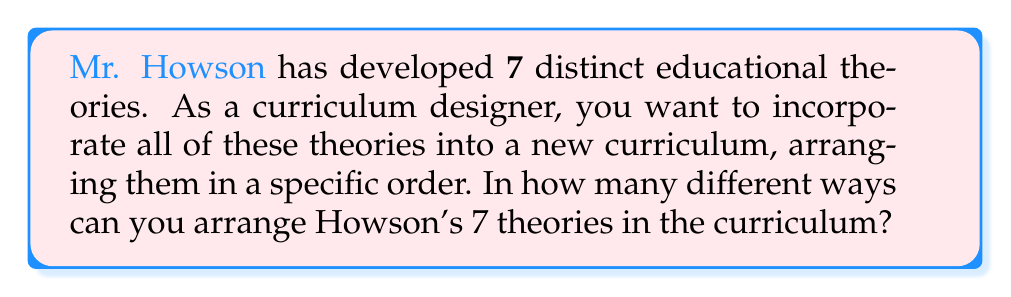What is the answer to this math problem? To solve this problem, we need to recognize that this is a permutation question. We are arranging all 7 theories in different orders, and each theory is used exactly once.

1) The number of ways to arrange n distinct objects is given by the factorial of n, denoted as n!

2) In this case, we have 7 distinct theories, so n = 7

3) Therefore, the number of ways to arrange Howson's 7 theories is:

   $$7! = 7 \times 6 \times 5 \times 4 \times 3 \times 2 \times 1$$

4) Let's calculate this:
   
   $$7! = 7 \times 6 \times 5 \times 4 \times 3 \times 2 \times 1 = 5040$$

Thus, there are 5040 different ways to arrange Howson's 7 educational theories in the curriculum.
Answer: 5040 